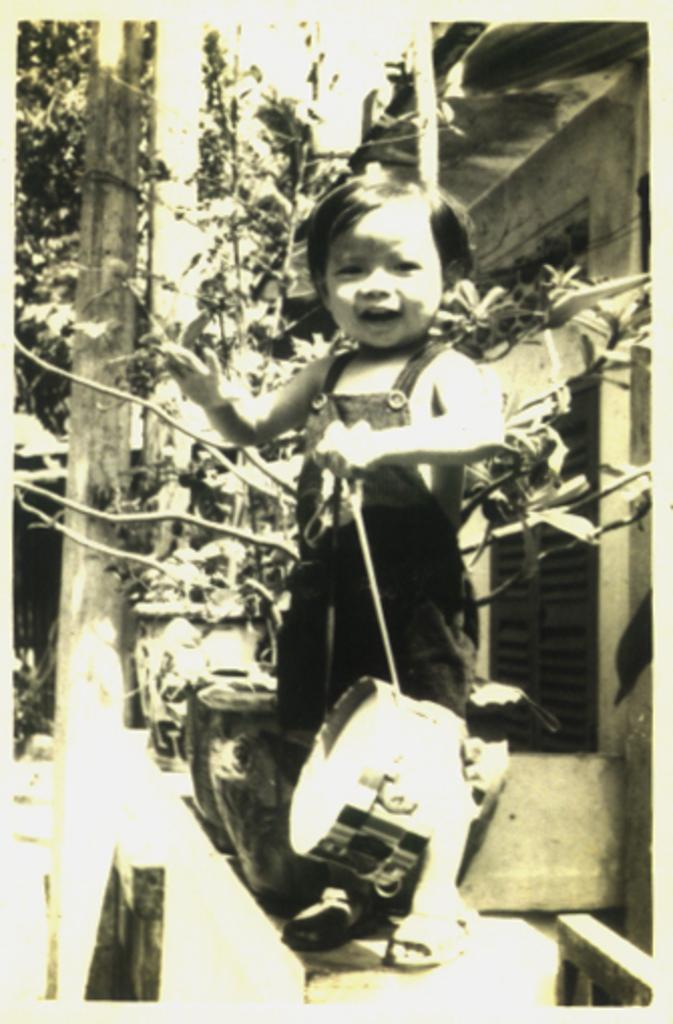What is the main subject in the foreground of the image? There is a kid in the foreground of the image. What is the kid holding in the image? The kid is holding an object. What can be seen in the background of the image? There are flower vases, a wall, a pole, and a window in the background of the image. What type of oatmeal is being served in the image? There is no oatmeal present in the image. How many cars can be seen in the image? There are no cars visible in the image. 